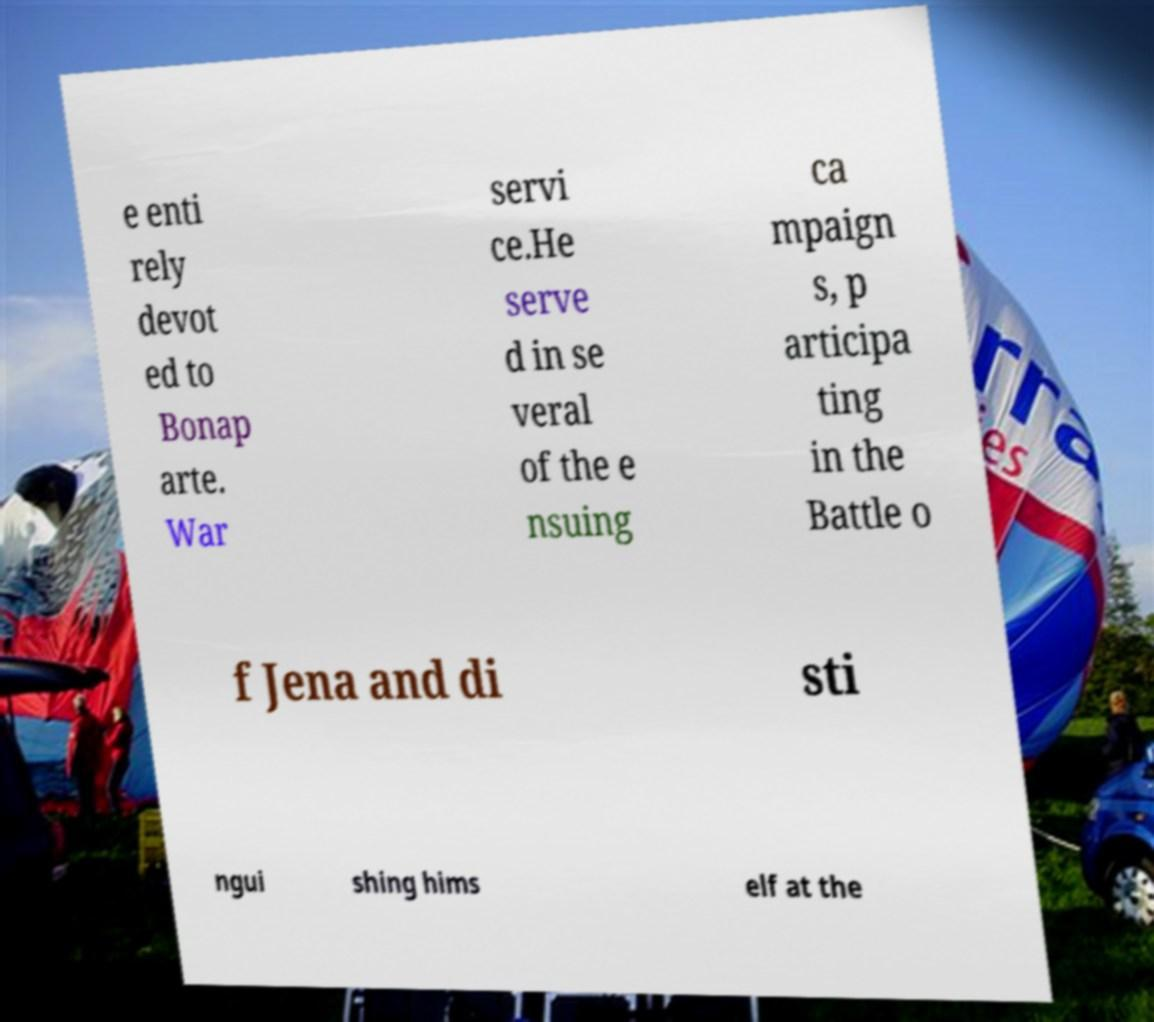For documentation purposes, I need the text within this image transcribed. Could you provide that? e enti rely devot ed to Bonap arte. War servi ce.He serve d in se veral of the e nsuing ca mpaign s, p articipa ting in the Battle o f Jena and di sti ngui shing hims elf at the 